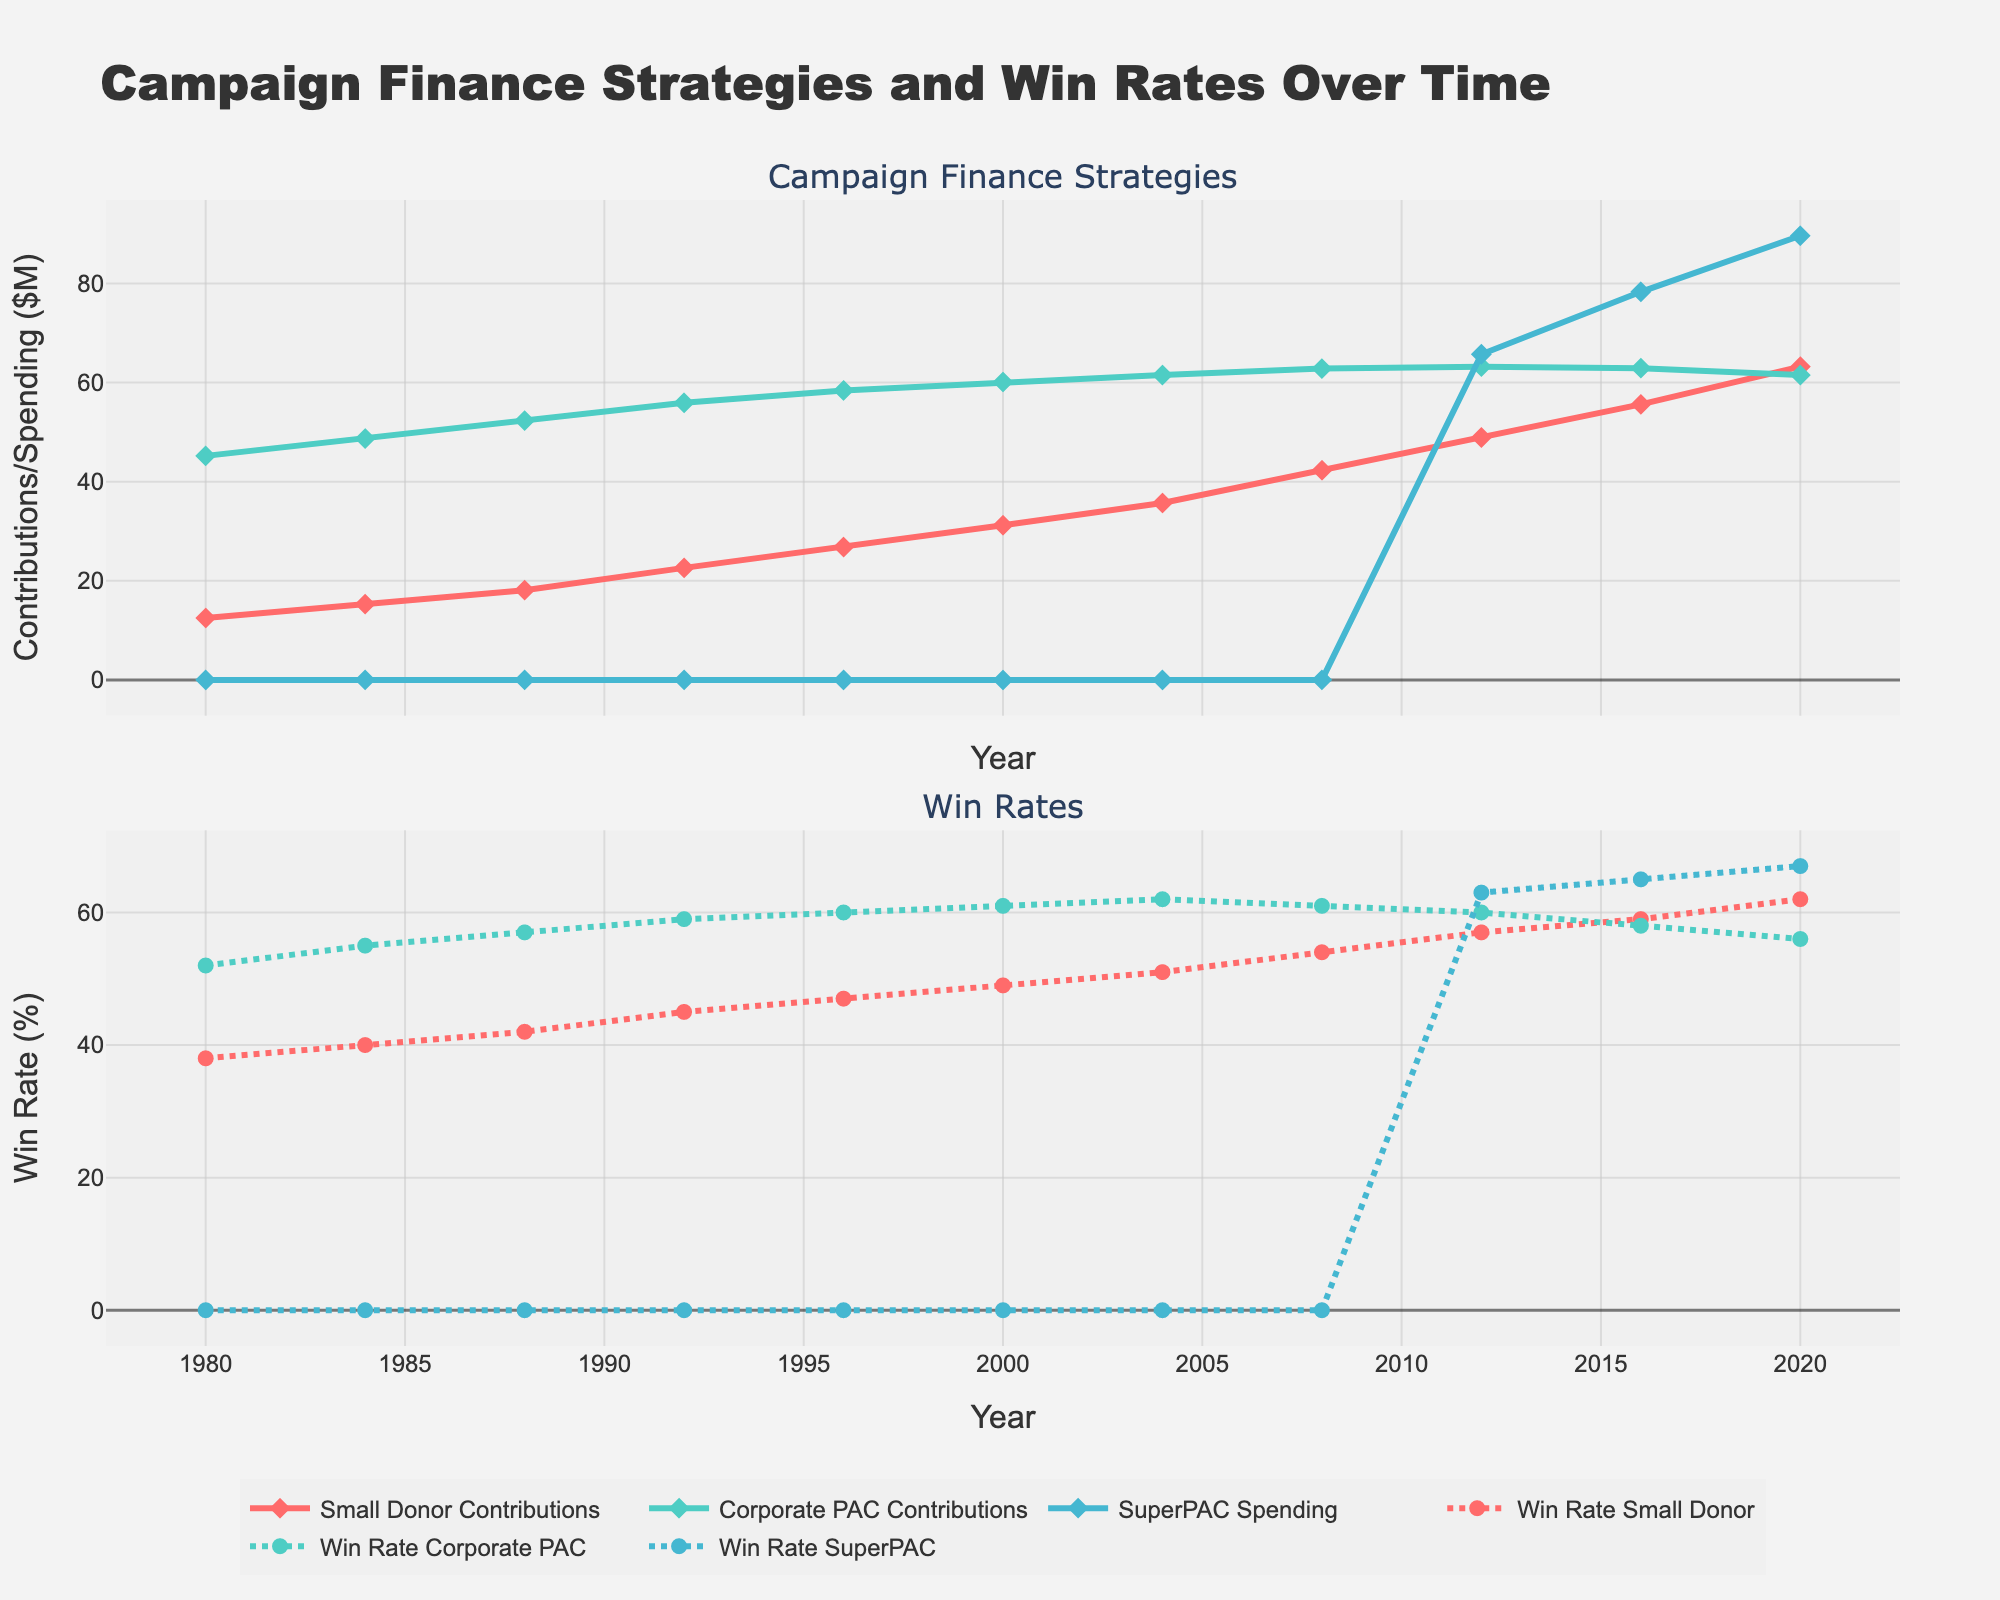What is the trend in Small Donor Contributions from 1980 to 2020? The line for Small Donor Contributions shows an upward trend from 1980 to 2020, indicating an increase in contributions over time.
Answer: Increasing How did the Win Rate for SuperPACs change from 2012 to 2020? The Win Rate for SuperPACs increased from 63% in 2012 to 65% in 2016, and then to 67% in 2020, as indicated by the upward trend of the dotted line for SuperPAC Win Rate.
Answer: Increased Which type of contribution saw the highest spending in 2020? SuperPAC Spending shows the highest value in 2020, reaching 89.6 million USD, compared to Small Donor Contributions and Corporate PAC Contributions.
Answer: SuperPAC Spending Did Corporate PAC Contributions and their Win Rate both follow the same trend over time? Corporate PAC Contributions increased from 1980 to the early 2000s but stabilized and slightly decreased afterwards, while the Win Rate showed an initial increase followed by a decrease after 2008. Thus, they did not follow the same trend.
Answer: No How did the Win Rate for Small Donor Contributions compare to Corporate PAC Contributions in 2008? In 2008, the Win Rate for Small Donor Contributions was 54%, while the Win Rate for Corporate PAC Contributions was 61%. Corporate PAC Contributions had a higher win rate.
Answer: Corporate PAC Contributions had a higher win rate What is the difference in SuperPAC Spending between 2012 and 2020? The SuperPAC Spending in 2012 was 65.7 million USD, and in 2020 it was 89.6 million USD. The difference is 89.6 - 65.7 = 23.9 million USD.
Answer: 23.9 million USD Which funding source had the highest Win Rate in 2020? In 2020, the Win Rate for Small Donor Contributions was 62%, Corporate PAC Contributions was 56%, and SuperPAC Spending was 67%. SuperPAC Spending had the highest Win Rate.
Answer: SuperPAC Spending What is the average Win Rate for Small Donor Contributions from 1980 to 2020? The Win Rates for Small Donor Contributions from 1980 to 2020 are [38, 40, 42, 45, 47, 49, 51, 54, 57, 59, 62]. The sum is 544, and the average is 544 / 11 = 49.45%.
Answer: 49.45% Which year had the largest increase in Win Rate for Small Donor Contributions? The largest increase in Win Rate for Small Donor Contributions occurred between 2004 and 2008, where the Win Rate increased from 51% to 54%, a difference of 3%.
Answer: Between 2004 and 2008 How did SuperPAC Spending affect the Win Rates between 2012 and 2020? From 2012 to 2020, as SuperPAC Spending increased from 65.7 million USD to 89.6 million USD, the Win Rate for SuperPAC candidates also increased from 63% to 67%, indicating a positive correlation.
Answer: Positive correlation 